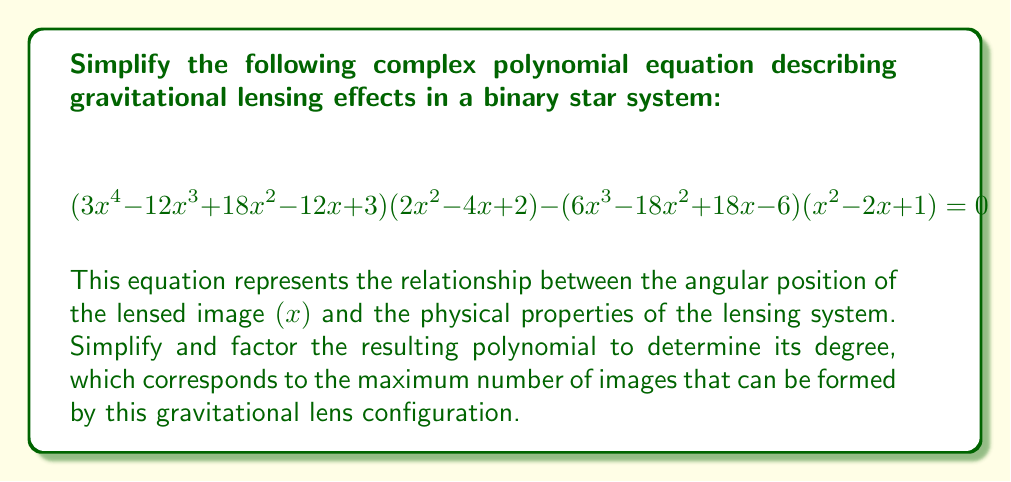Show me your answer to this math problem. Let's approach this step-by-step:

1) First, let's expand the left side of the equation:

   $(3x^4 - 12x^3 + 18x^2 - 12x + 3)(2x^2 - 4x + 2) - (6x^3 - 18x^2 + 18x - 6)(x^2 - 2x + 1) = 0$

2) Multiply the terms in the first parentheses:
   $6x^6 - 24x^5 + 36x^4 - 24x^3 + 6x^2$
   $-12x^5 + 48x^4 - 72x^3 + 48x^2 - 12x$
   $+6x^4 - 24x^3 + 36x^2 - 24x + 6$

3) Multiply the terms in the second parentheses:
   $6x^5 - 18x^4 + 18x^3 - 6x^2$
   $-12x^4 + 36x^3 - 36x^2 + 12x$
   $+6x^3 - 18x^2 + 18x - 6$

4) Subtract the second result from the first:

   $6x^6 - 24x^5 + 36x^4 - 24x^3 + 6x^2$
   $-12x^5 + 48x^4 - 72x^3 + 48x^2 - 12x$
   $+6x^4 - 24x^3 + 36x^2 - 24x + 6$
   $-6x^5 + 18x^4 - 18x^3 + 6x^2$
   $+12x^4 - 36x^3 + 36x^2 - 12x$
   $-6x^3 + 18x^2 - 18x + 6$

5) Combine like terms:

   $6x^6 - 30x^5 + 60x^4 - 60x^3 + 30x^2 - 6x = 0$

6) Factor out the greatest common factor:

   $6(x^6 - 5x^5 + 10x^4 - 10x^3 + 5x^2 - x) = 0$

7) The polynomial inside the parentheses can be factored as a difference of squares:

   $6(x^3 - x)^2 = 0$

8) Factor $x^3 - x$ further:

   $6x^2(x - 1)^2 = 0$

Therefore, the simplified and factored equation is:

$$6x^2(x - 1)^2 = 0$$

The degree of this polynomial is 4, which means this gravitational lens configuration can produce a maximum of 4 images.
Answer: $6x^2(x - 1)^2 = 0$ 